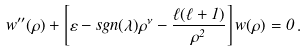Convert formula to latex. <formula><loc_0><loc_0><loc_500><loc_500>w ^ { \prime \prime } ( \rho ) + \left [ \varepsilon - s g n ( \lambda ) \rho ^ { \nu } - \frac { \ell ( \ell + 1 ) } { \rho ^ { 2 } } \right ] w ( \rho ) = 0 \, .</formula> 